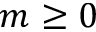Convert formula to latex. <formula><loc_0><loc_0><loc_500><loc_500>m \geq 0</formula> 